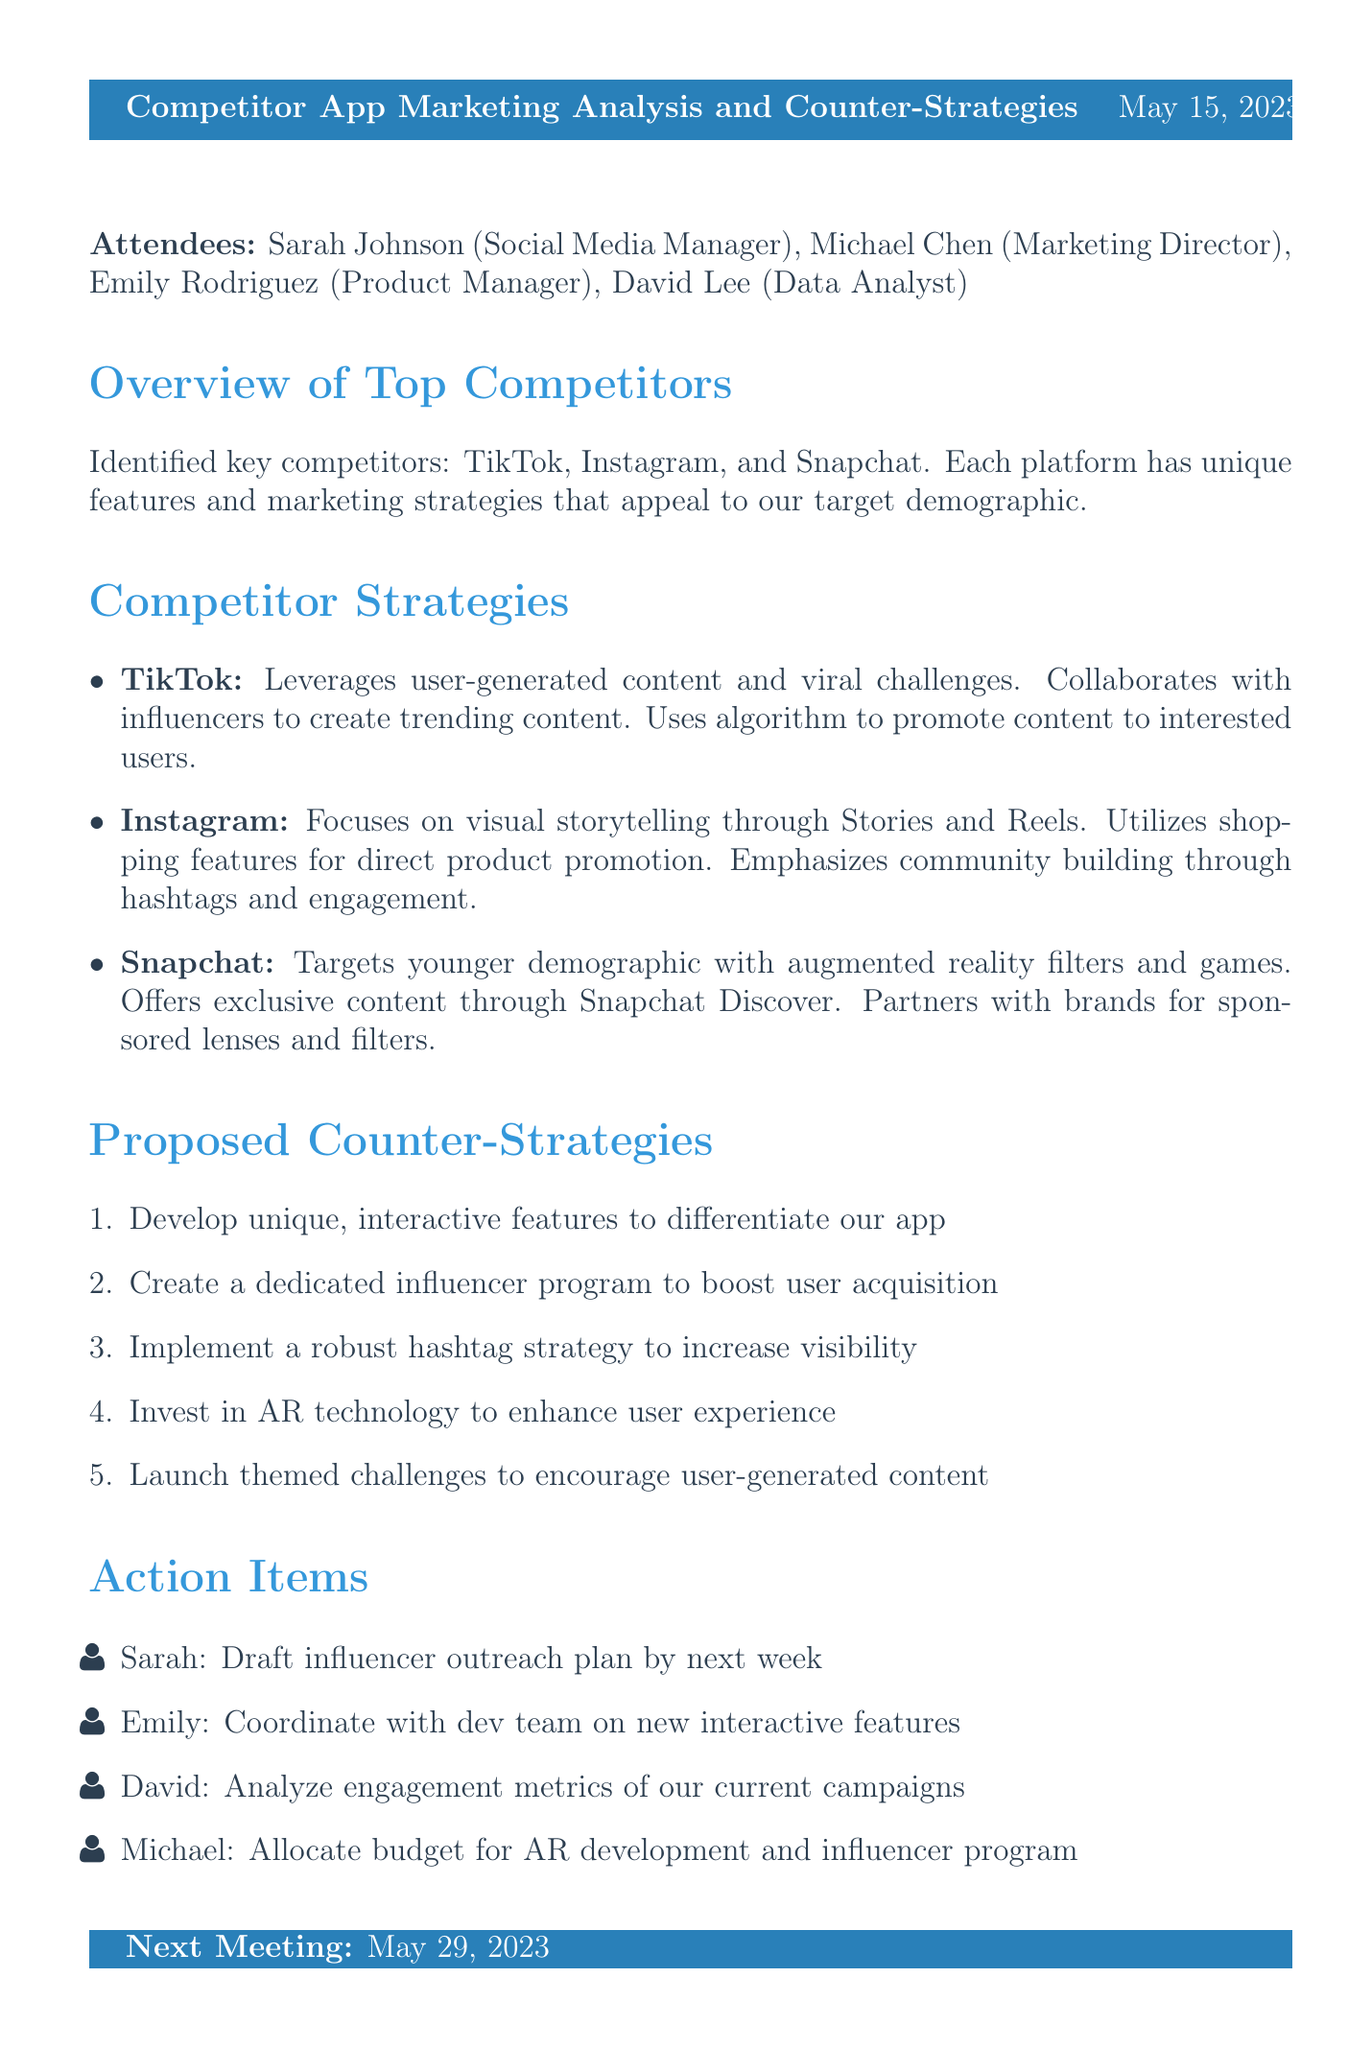What is the meeting title? The meeting title is indicated at the beginning of the document.
Answer: Competitor App Marketing Analysis and Counter-Strategies Who is the Social Media Manager? The attendees section names Sarah Johnson as the Social Media Manager.
Answer: Sarah Johnson What date was the meeting held? The date of the meeting is clearly stated in the header.
Answer: May 15, 2023 Which competitor focuses on visual storytelling? The document lists Instagram as focusing on visual storytelling.
Answer: Instagram What is one proposed counter-strategy? The proposed counter-strategies are listed in a numbered format, one example can be selected.
Answer: Develop unique, interactive features to differentiate our app How many competitors were identified? The Overview of Top Competitors section mentions the number of key competitors identified.
Answer: Three What action item is assigned to Emily? The Action Items section specifies what Emily is responsible for.
Answer: Coordinate with dev team on new interactive features What is the next meeting date? The next meeting date is stated at the end of the document.
Answer: May 29, 2023 